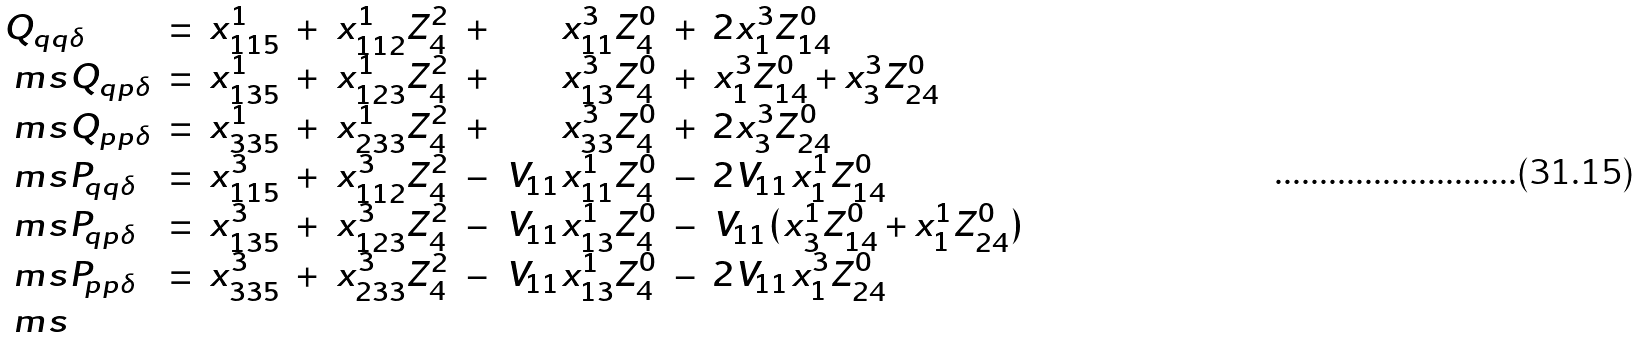Convert formula to latex. <formula><loc_0><loc_0><loc_500><loc_500>\begin{array} { l c r r r r r r l } Q _ { q q \delta } & = & x ^ { 1 } _ { 1 1 5 } & + & x ^ { 1 } _ { 1 1 2 } Z ^ { 2 } _ { 4 } & + & x ^ { 3 } _ { 1 1 } Z ^ { 0 } _ { 4 } & + & 2 x ^ { 3 } _ { 1 } Z ^ { 0 } _ { 1 4 } \\ { \ m s } Q _ { q p \delta } & = & x ^ { 1 } _ { 1 3 5 } & + & x ^ { 1 } _ { 1 2 3 } Z ^ { 2 } _ { 4 } & + & x ^ { 3 } _ { 1 3 } Z ^ { 0 } _ { 4 } & + & x ^ { 3 } _ { 1 } Z ^ { 0 } _ { 1 4 } + x ^ { 3 } _ { 3 } Z ^ { 0 } _ { 2 4 } \\ { \ m s } Q _ { p p \delta } & = & x ^ { 1 } _ { 3 3 5 } & + & x ^ { 1 } _ { 2 3 3 } Z ^ { 2 } _ { 4 } & + & x ^ { 3 } _ { 3 3 } Z ^ { 0 } _ { 4 } & + & 2 x ^ { 3 } _ { 3 } Z ^ { 0 } _ { 2 4 } \\ { \ m s } P _ { q q \delta } & = & x ^ { 3 } _ { 1 1 5 } & + & x ^ { 3 } _ { 1 1 2 } Z ^ { 2 } _ { 4 } & - & V _ { 1 1 } x ^ { 1 } _ { 1 1 } Z ^ { 0 } _ { 4 } & - & 2 V _ { 1 1 } x ^ { 1 } _ { 1 } Z ^ { 0 } _ { 1 4 } \\ { \ m s } P _ { q p \delta } & = & x ^ { 3 } _ { 1 3 5 } & + & x ^ { 3 } _ { 1 2 3 } Z ^ { 2 } _ { 4 } & - & V _ { 1 1 } x ^ { 1 } _ { 1 3 } Z ^ { 0 } _ { 4 } & - & V _ { 1 1 } ( x ^ { 1 } _ { 3 } Z ^ { 0 } _ { 1 4 } + x ^ { 1 } _ { 1 } Z ^ { 0 } _ { 2 4 } ) \\ { \ m s } P _ { p p \delta } & = & x ^ { 3 } _ { 3 3 5 } & + & x ^ { 3 } _ { 2 3 3 } Z ^ { 2 } _ { 4 } & - & V _ { 1 1 } x ^ { 1 } _ { 1 3 } Z ^ { 0 } _ { 4 } & - & 2 V _ { 1 1 } x ^ { 3 } _ { 1 } Z ^ { 0 } _ { 2 4 } \\ { \ m s } \end{array}</formula> 